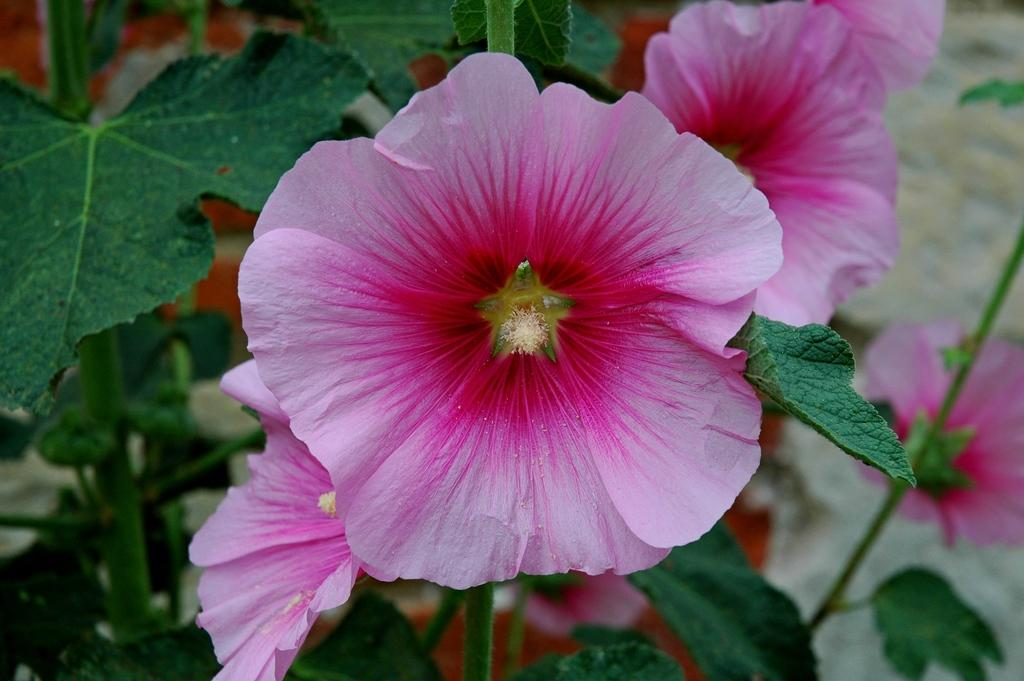What type of flowers can be seen in the image? There are pink flowers in the image. Where are the pink flowers located? The pink flowers are on plants. What type of trouble is the silver base experiencing in the image? There is no mention of a silver base or any trouble in the image; it only features pink flowers on plants. 